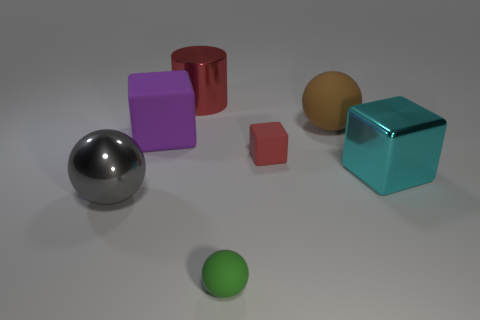How might the materials of these objects differ in the real world? In reality, objects similar to these would likely be made from various materials. The metallic sphere could be made of polished steel or aluminum, the cubes might be of plastics or painted wood, and the cylinder could be ceramic or enameled metal. Each material would have distinct tactile sensations and physical properties, such as weight and temperature conductivity. 